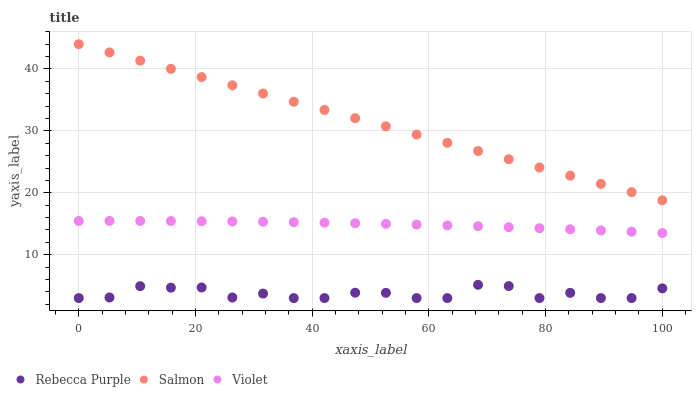Does Rebecca Purple have the minimum area under the curve?
Answer yes or no. Yes. Does Salmon have the maximum area under the curve?
Answer yes or no. Yes. Does Violet have the minimum area under the curve?
Answer yes or no. No. Does Violet have the maximum area under the curve?
Answer yes or no. No. Is Salmon the smoothest?
Answer yes or no. Yes. Is Rebecca Purple the roughest?
Answer yes or no. Yes. Is Violet the smoothest?
Answer yes or no. No. Is Violet the roughest?
Answer yes or no. No. Does Rebecca Purple have the lowest value?
Answer yes or no. Yes. Does Violet have the lowest value?
Answer yes or no. No. Does Salmon have the highest value?
Answer yes or no. Yes. Does Violet have the highest value?
Answer yes or no. No. Is Rebecca Purple less than Violet?
Answer yes or no. Yes. Is Salmon greater than Violet?
Answer yes or no. Yes. Does Rebecca Purple intersect Violet?
Answer yes or no. No. 